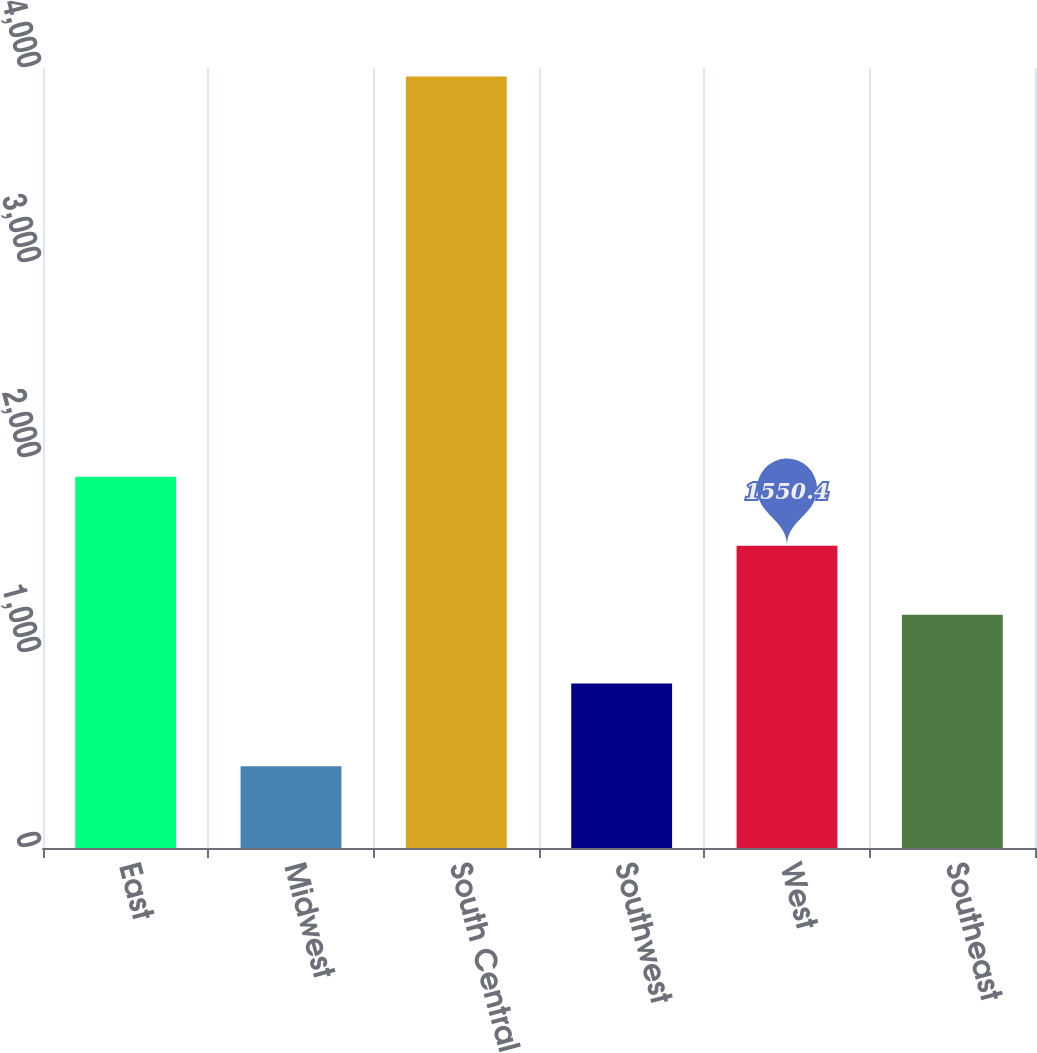Convert chart to OTSL. <chart><loc_0><loc_0><loc_500><loc_500><bar_chart><fcel>East<fcel>Midwest<fcel>South Central<fcel>Southwest<fcel>West<fcel>Southeast<nl><fcel>1904.1<fcel>419<fcel>3956<fcel>843<fcel>1550.4<fcel>1196.7<nl></chart> 